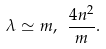<formula> <loc_0><loc_0><loc_500><loc_500>\lambda \simeq m , \ \frac { 4 n ^ { 2 } } { m } .</formula> 